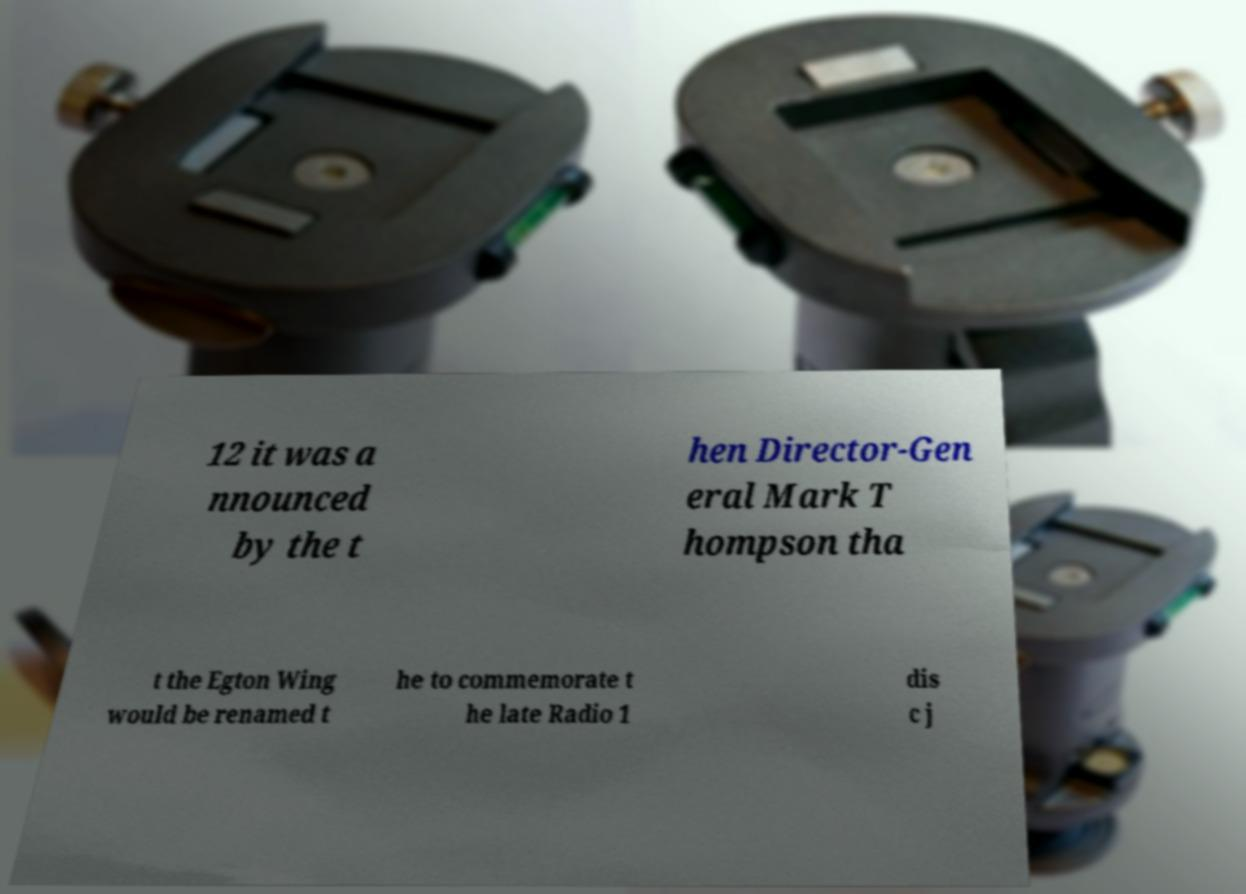Could you extract and type out the text from this image? 12 it was a nnounced by the t hen Director-Gen eral Mark T hompson tha t the Egton Wing would be renamed t he to commemorate t he late Radio 1 dis c j 